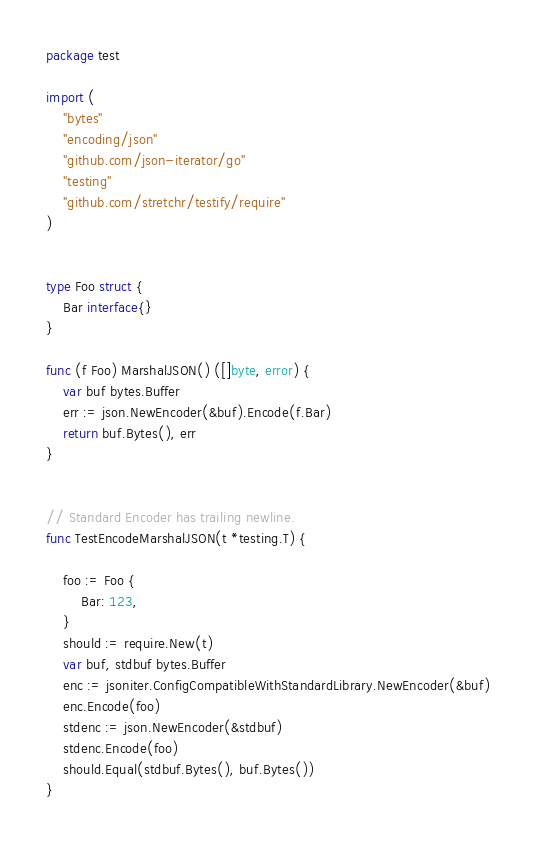Convert code to text. <code><loc_0><loc_0><loc_500><loc_500><_Go_>package test

import (
	"bytes"
	"encoding/json"
	"github.com/json-iterator/go"
	"testing"
	"github.com/stretchr/testify/require"
)


type Foo struct {
	Bar interface{}
}

func (f Foo) MarshalJSON() ([]byte, error) {
	var buf bytes.Buffer
	err := json.NewEncoder(&buf).Encode(f.Bar)
	return buf.Bytes(), err
}


// Standard Encoder has trailing newline.
func TestEncodeMarshalJSON(t *testing.T) {

	foo := Foo {
		Bar: 123,
	}
	should := require.New(t)
	var buf, stdbuf bytes.Buffer
	enc := jsoniter.ConfigCompatibleWithStandardLibrary.NewEncoder(&buf)
	enc.Encode(foo)
	stdenc := json.NewEncoder(&stdbuf)
	stdenc.Encode(foo)
	should.Equal(stdbuf.Bytes(), buf.Bytes())
}


</code> 